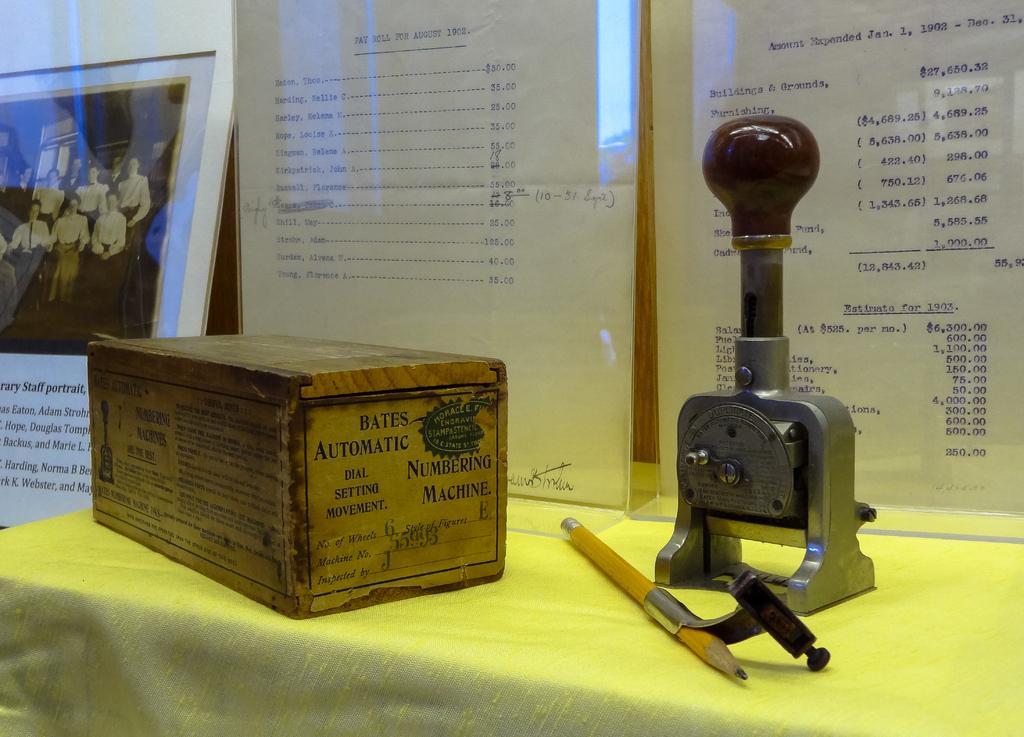Please provide a concise description of this image. In this image there is a table with some box, stamp board and pencil beside that there is a display board with some note and on other side there is a photo frame. 